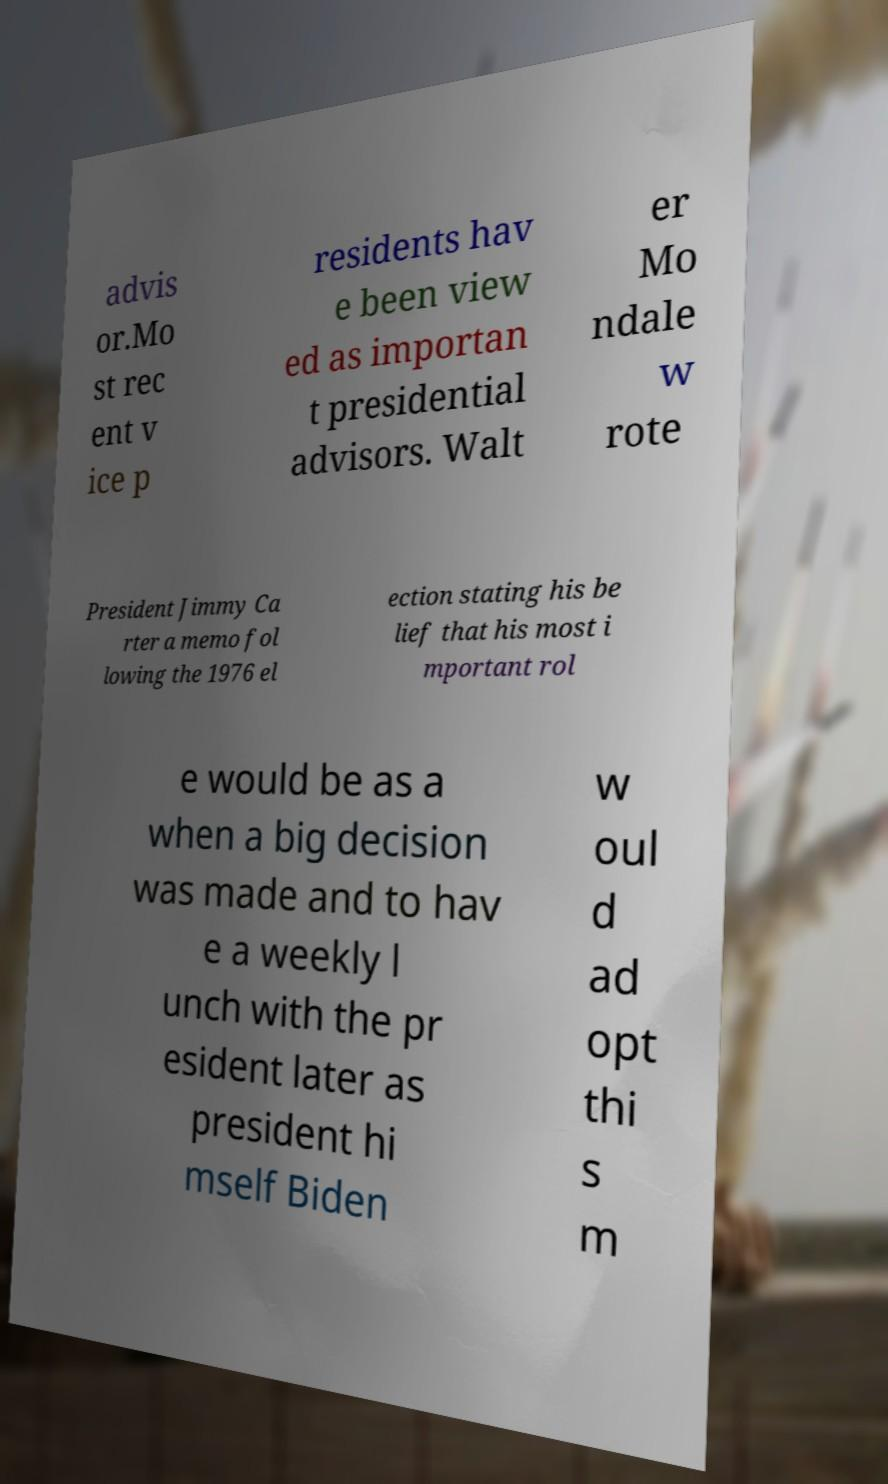Please read and relay the text visible in this image. What does it say? advis or.Mo st rec ent v ice p residents hav e been view ed as importan t presidential advisors. Walt er Mo ndale w rote President Jimmy Ca rter a memo fol lowing the 1976 el ection stating his be lief that his most i mportant rol e would be as a when a big decision was made and to hav e a weekly l unch with the pr esident later as president hi mself Biden w oul d ad opt thi s m 